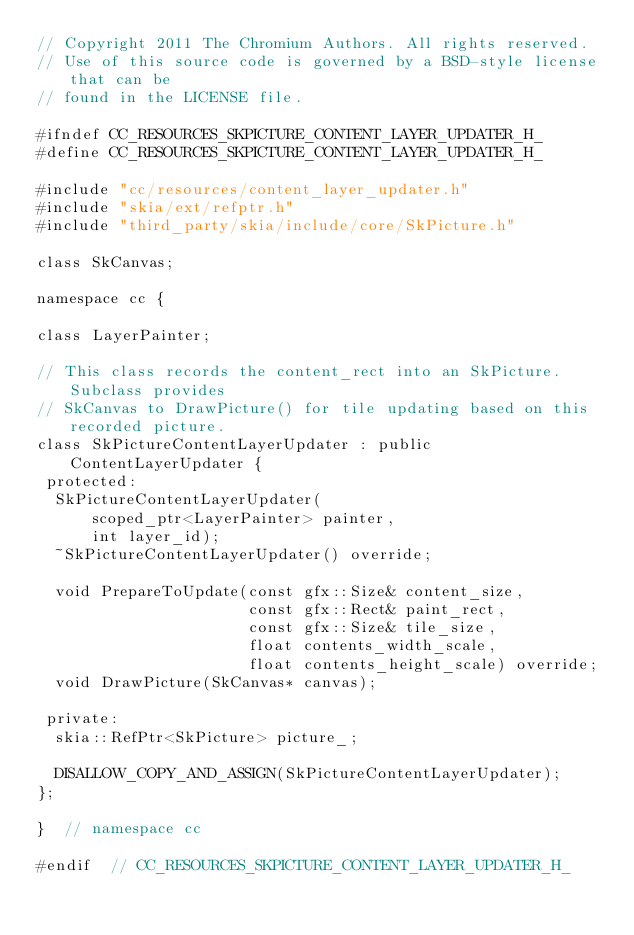<code> <loc_0><loc_0><loc_500><loc_500><_C_>// Copyright 2011 The Chromium Authors. All rights reserved.
// Use of this source code is governed by a BSD-style license that can be
// found in the LICENSE file.

#ifndef CC_RESOURCES_SKPICTURE_CONTENT_LAYER_UPDATER_H_
#define CC_RESOURCES_SKPICTURE_CONTENT_LAYER_UPDATER_H_

#include "cc/resources/content_layer_updater.h"
#include "skia/ext/refptr.h"
#include "third_party/skia/include/core/SkPicture.h"

class SkCanvas;

namespace cc {

class LayerPainter;

// This class records the content_rect into an SkPicture. Subclass provides
// SkCanvas to DrawPicture() for tile updating based on this recorded picture.
class SkPictureContentLayerUpdater : public ContentLayerUpdater {
 protected:
  SkPictureContentLayerUpdater(
      scoped_ptr<LayerPainter> painter,
      int layer_id);
  ~SkPictureContentLayerUpdater() override;

  void PrepareToUpdate(const gfx::Size& content_size,
                       const gfx::Rect& paint_rect,
                       const gfx::Size& tile_size,
                       float contents_width_scale,
                       float contents_height_scale) override;
  void DrawPicture(SkCanvas* canvas);

 private:
  skia::RefPtr<SkPicture> picture_;

  DISALLOW_COPY_AND_ASSIGN(SkPictureContentLayerUpdater);
};

}  // namespace cc

#endif  // CC_RESOURCES_SKPICTURE_CONTENT_LAYER_UPDATER_H_
</code> 